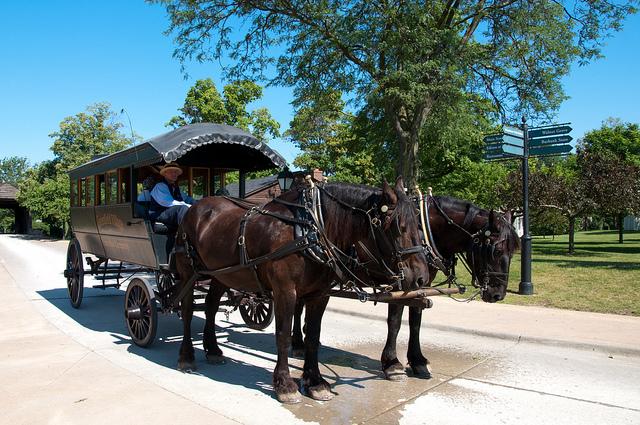What marking do both horses share?
Answer briefly. None. What are the horses there to do?
Keep it brief. Pull carriage. Do both horses look the same?
Concise answer only. Yes. Is the ground wet at all?
Be succinct. Yes. 